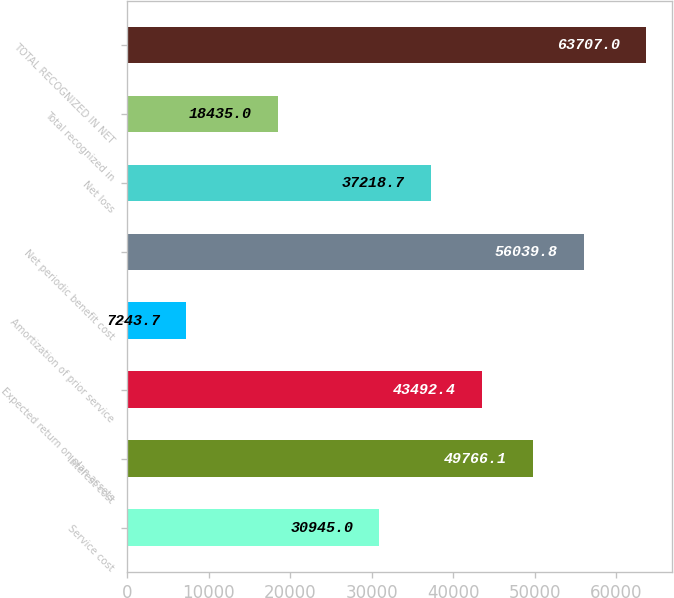Convert chart to OTSL. <chart><loc_0><loc_0><loc_500><loc_500><bar_chart><fcel>Service cost<fcel>Interest cost<fcel>Expected return on plan assets<fcel>Amortization of prior service<fcel>Net periodic benefit cost<fcel>Net loss<fcel>Total recognized in<fcel>TOTAL RECOGNIZED IN NET<nl><fcel>30945<fcel>49766.1<fcel>43492.4<fcel>7243.7<fcel>56039.8<fcel>37218.7<fcel>18435<fcel>63707<nl></chart> 